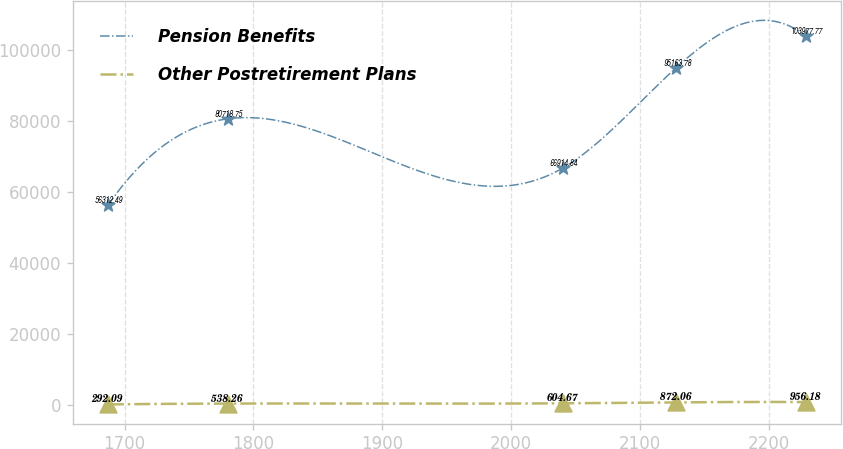Convert chart. <chart><loc_0><loc_0><loc_500><loc_500><line_chart><ecel><fcel>Pension Benefits<fcel>Other Postretirement Plans<nl><fcel>1686.96<fcel>56312.5<fcel>292.09<nl><fcel>1780.01<fcel>80718.8<fcel>538.26<nl><fcel>2040.37<fcel>66914.8<fcel>604.67<nl><fcel>2128.18<fcel>95163.8<fcel>872.06<nl><fcel>2228.71<fcel>103978<fcel>956.18<nl></chart> 